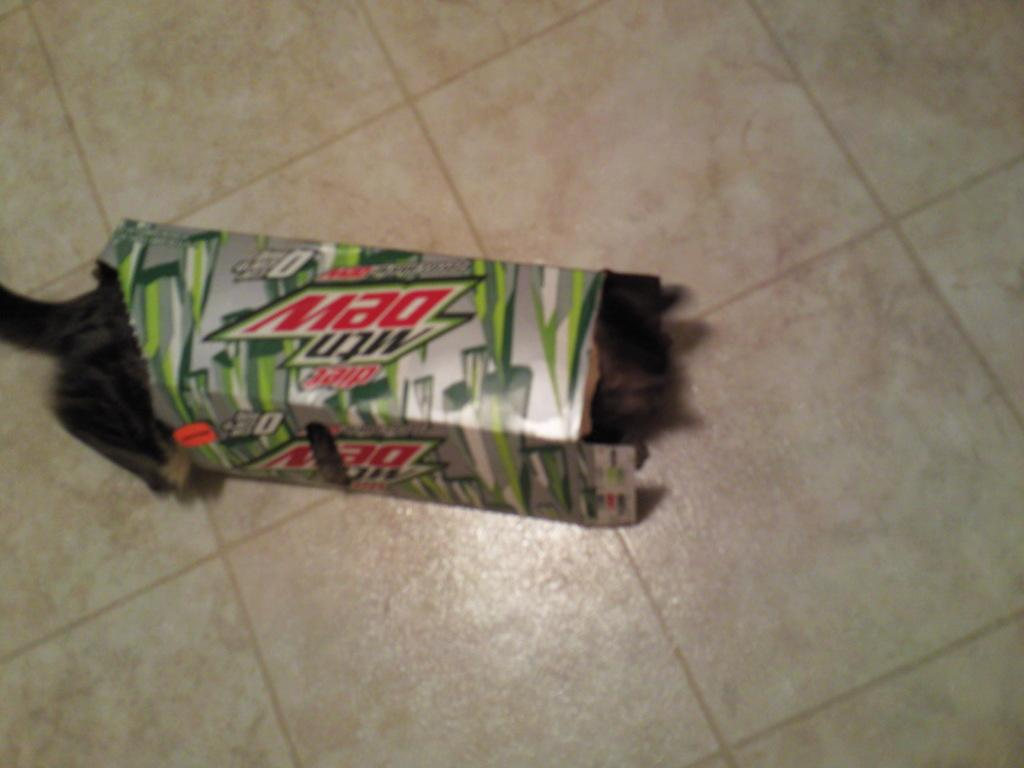What is placed on the floor in the image? There is a Mountain Dew box on the floor. Can you describe the object on the floor? It is a Mountain Dew box. What type of knot is used to secure the Mountain Dew box in the image? There is no knot present in the image, as the Mountain Dew box is simply placed on the floor. 